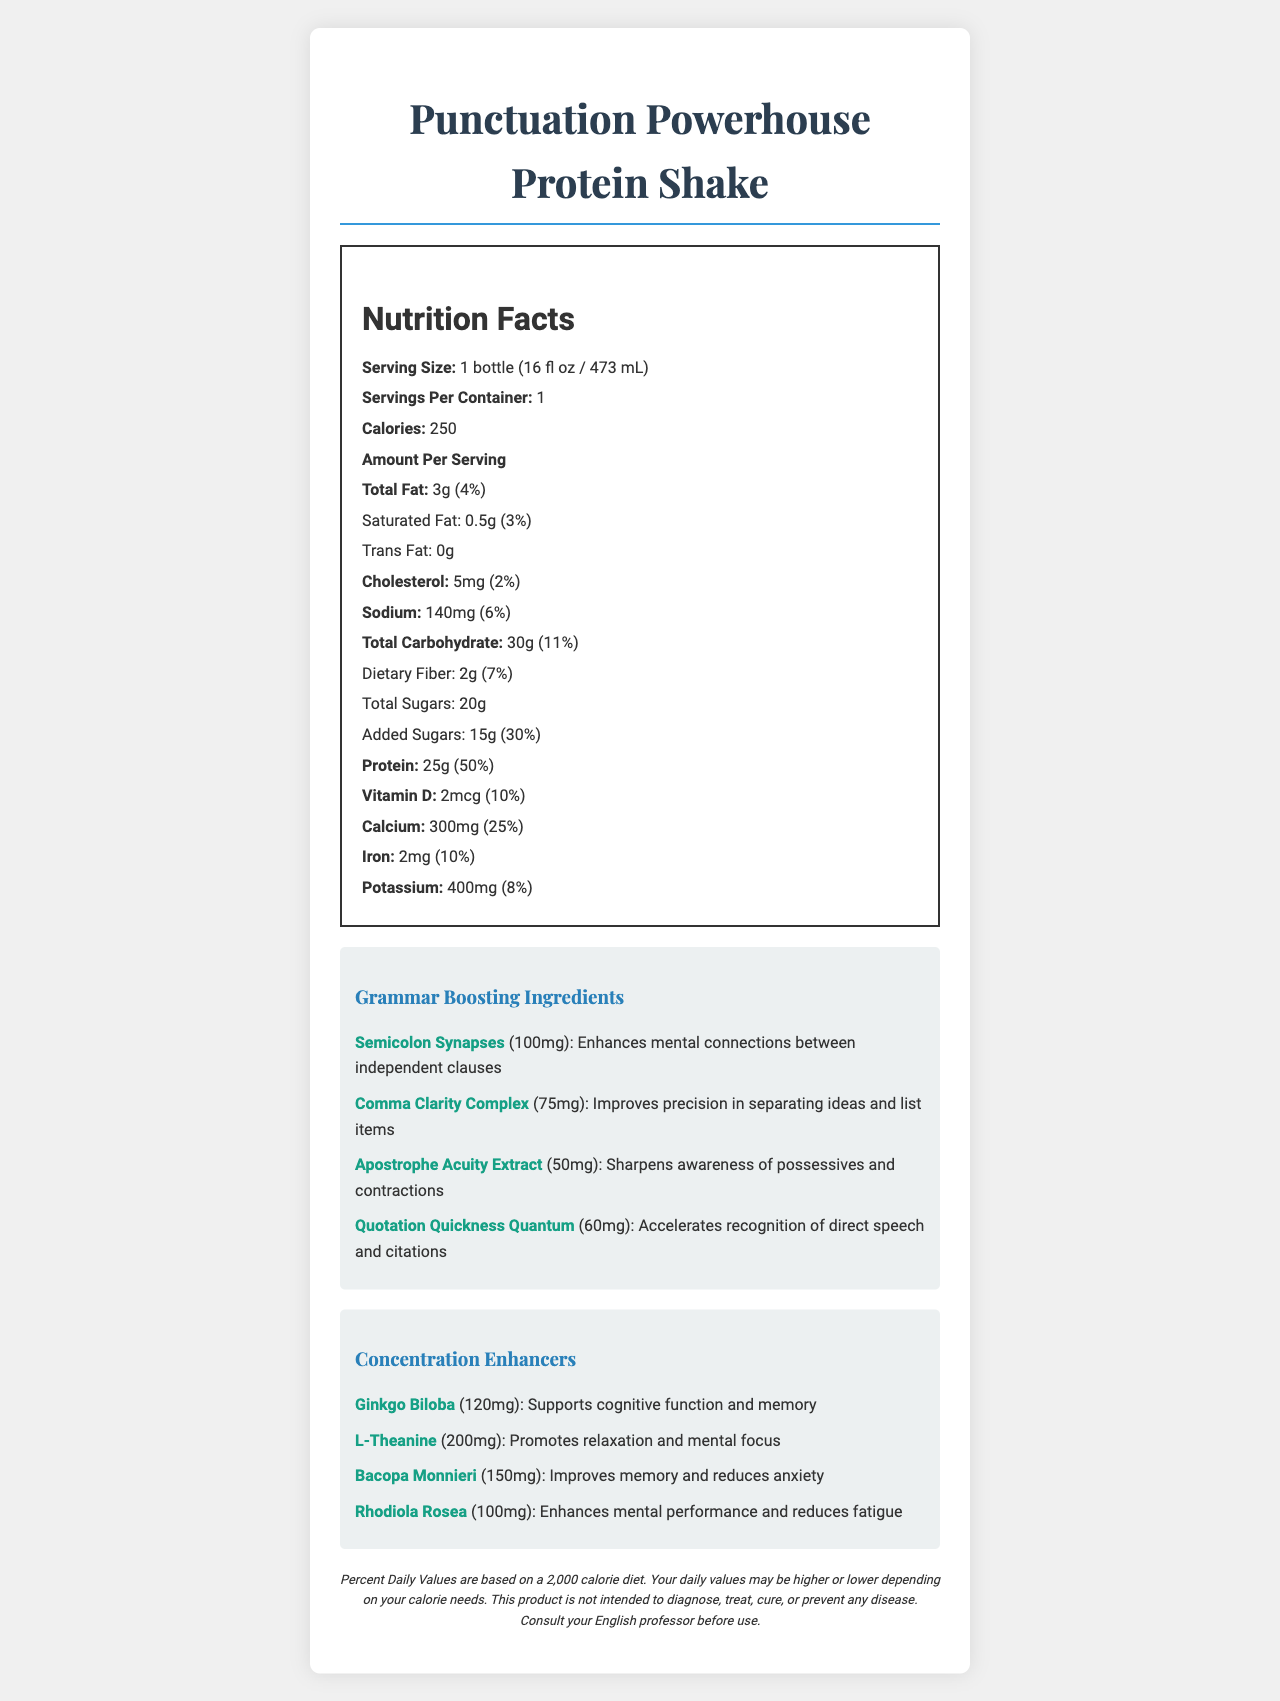what is the serving size of the Punctuation Powerhouse Protein Shake? The serving size is clearly stated at the beginning of the Nutrition Facts section as "Serving Size: 1 bottle (16 fl oz / 473 mL)."
Answer: 1 bottle (16 fl oz / 473 mL) how many calories are there per serving? The document lists the calories per serving as 250, found in the Nutrition Facts section under "Calories."
Answer: 250 which ingredient enhances mental connections between independent clauses? In the Grammar Boosting Ingredients section, it states that "Semicolon Synapses (100mg): Enhances mental connections between independent clauses."
Answer: Semicolon Synapses how much protein is in one bottle? The amount of protein per serving is listed as 25g under the Nutrition Facts section, specifically under "Protein."
Answer: 25g what is the percentage of daily value for calcium in this shake? The daily value percentage for calcium is listed as "25%" in the Nutrition Facts section next to "Calcium."
Answer: 25% which ingredient promotes relaxation and mental focus? 
A. Ginkgo Biloba 
B. L-Theanine 
C. Bacopa Monnieri 
D. Rhodiola Rosea In the Concentration Enhancers section, L-Theanine is listed with the benefit "Promotes relaxation and mental focus."
Answer: B. L-Theanine which of the following has the highest amount in milligrams?
I. Semicolon Synapses
II. Comma Clarity Complex
III. Apostrophe Acuity Extract
IV. Quotation Quickness Quantum In the Grammar Boosting Ingredients section, Semicolon Synapses has the highest amount of 100mg compared to the other options listed.
Answer: I. Semicolon Synapses is there any trans fat in the shake? The document states "Trans Fat: 0g" in the Nutrition Facts section.
Answer: No please summarize the key nutritional information and benefits provided by the Punctuation Powerhouse Protein Shake. The shake offers a blend of nutrients that support both physical and mental health, including high protein content and special additives aimed at improving grammar skills and concentration.
Answer: The Punctuation Powerhouse Protein Shake provides 250 calories per serving, with notable amounts of protein (25g, 50% DV), calcium (25% DV), and other essential nutrients. It contains unique grammar-boosting ingredients like Semicolon Synapses and concentration enhancers like Ginkgo Biloba to support mental alertness and cognitive function. what is the cost of the Punctuation Powerhouse Protein Shake? The document does not provide any information regarding the price of the protein shake.
Answer: Cannot be determined 